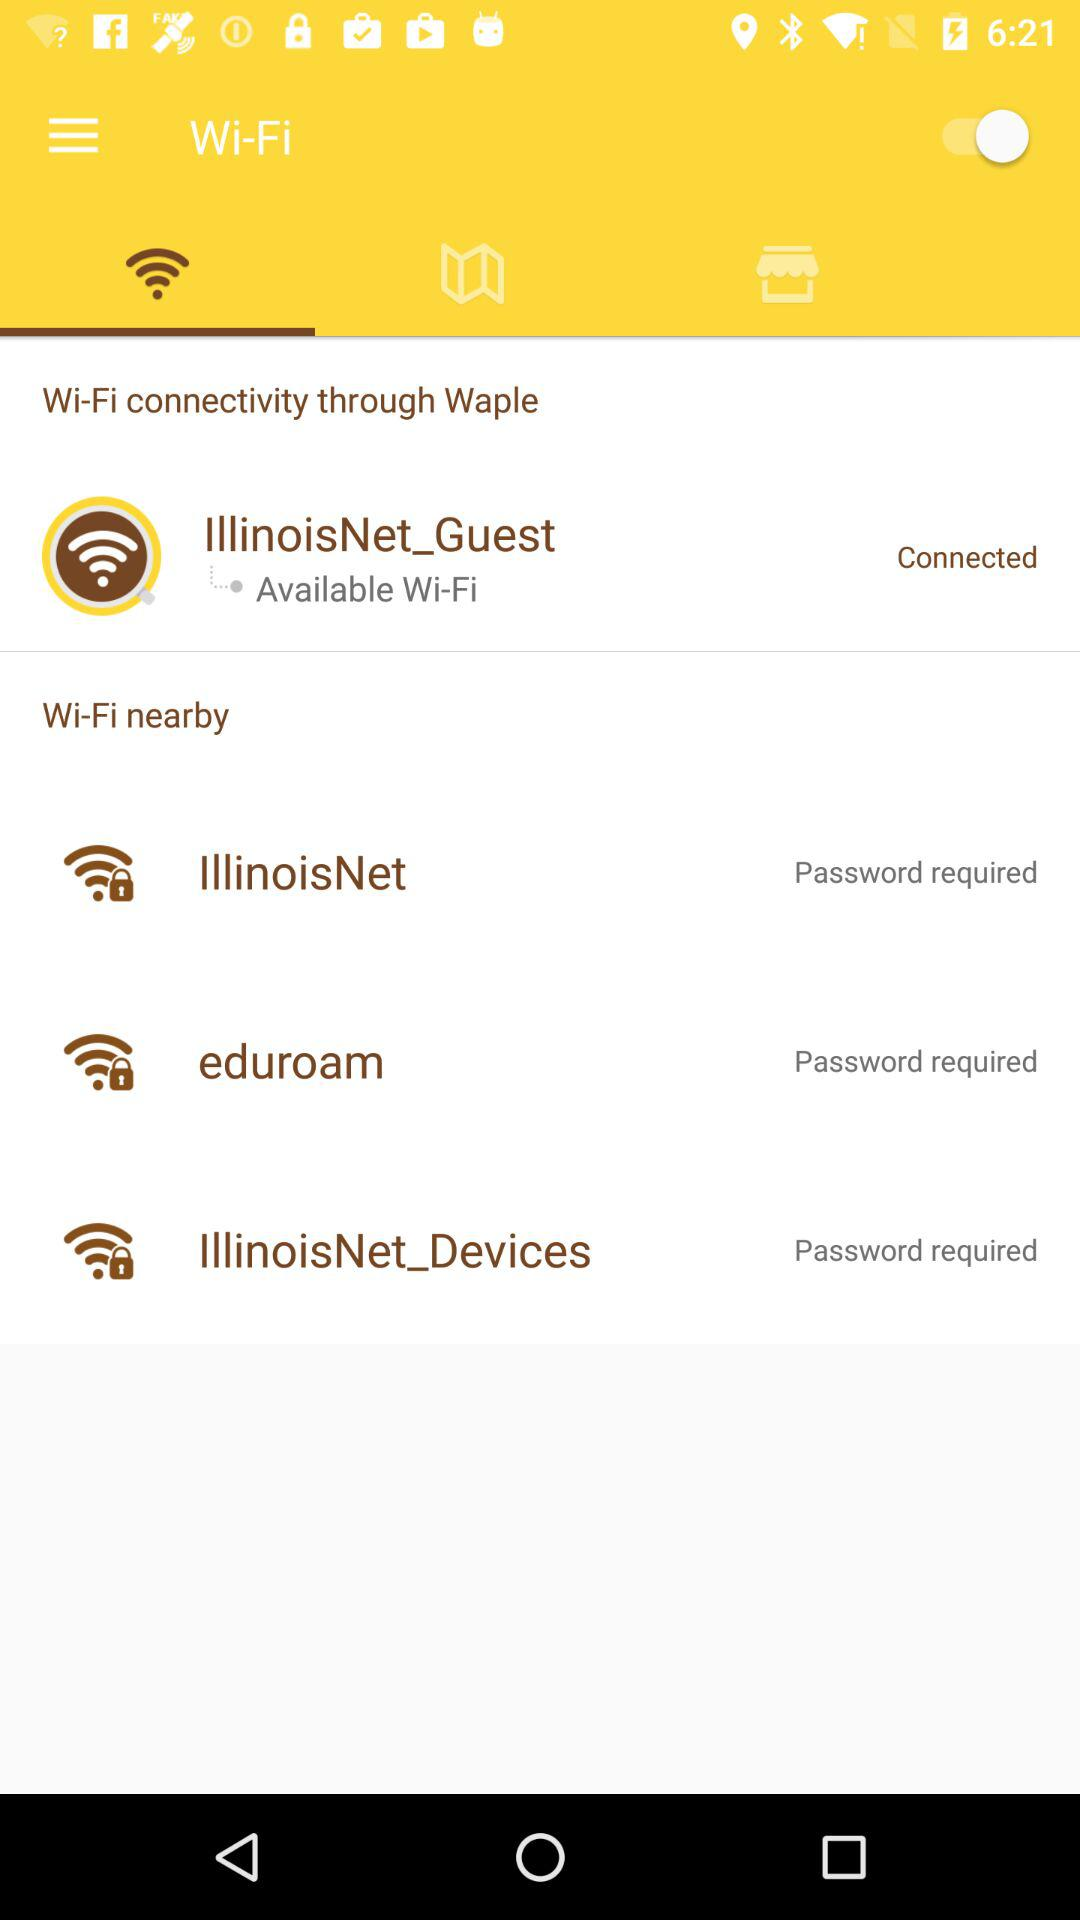What is required to connect with Illinois Net? To connect with Illinois Net, a password is required. 